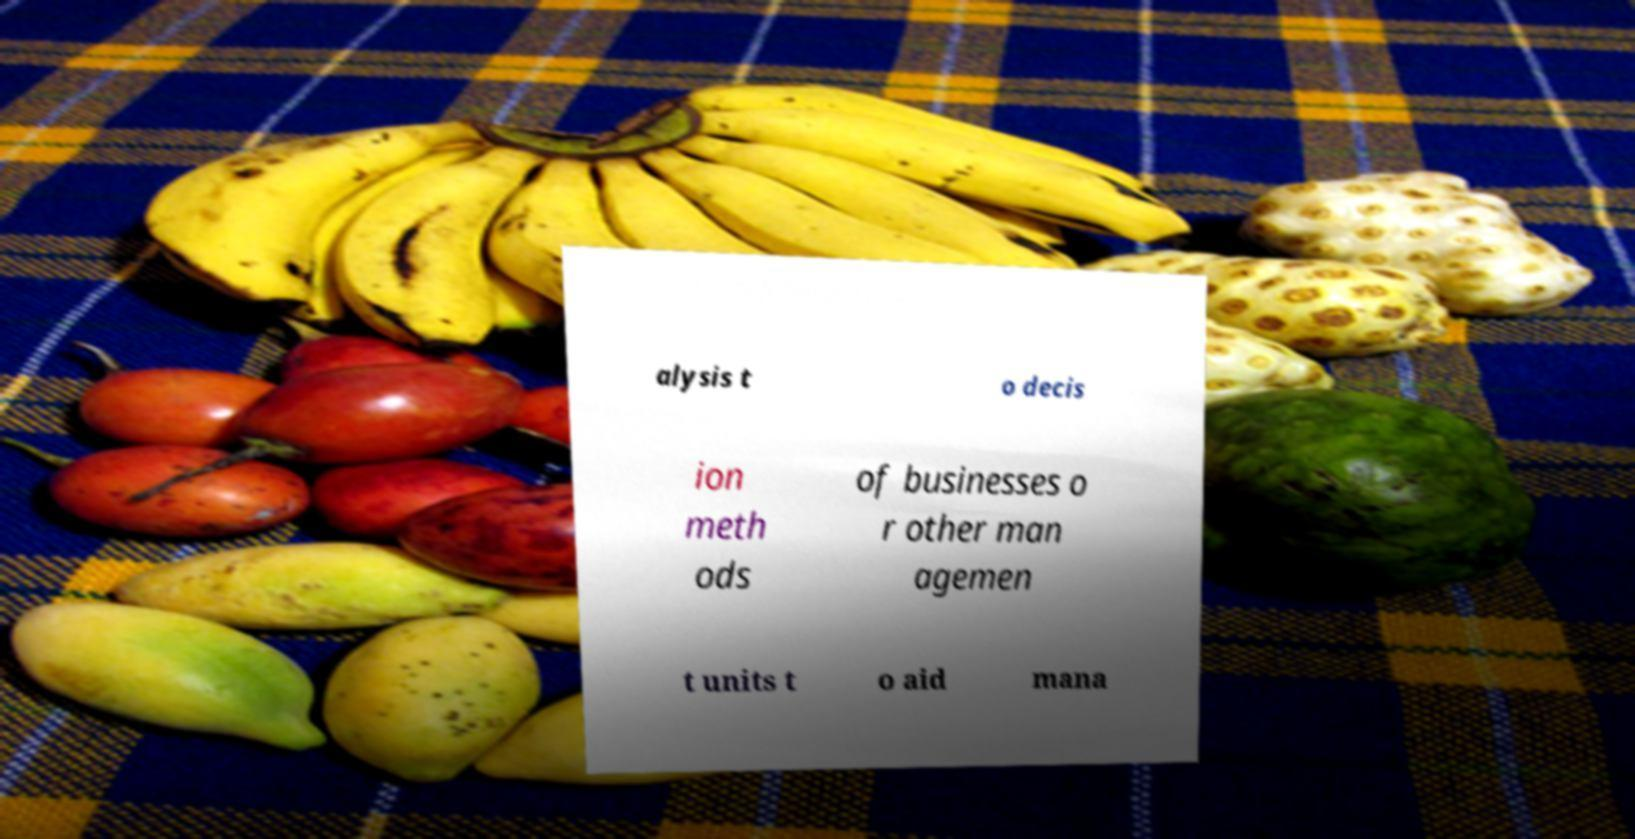What messages or text are displayed in this image? I need them in a readable, typed format. alysis t o decis ion meth ods of businesses o r other man agemen t units t o aid mana 